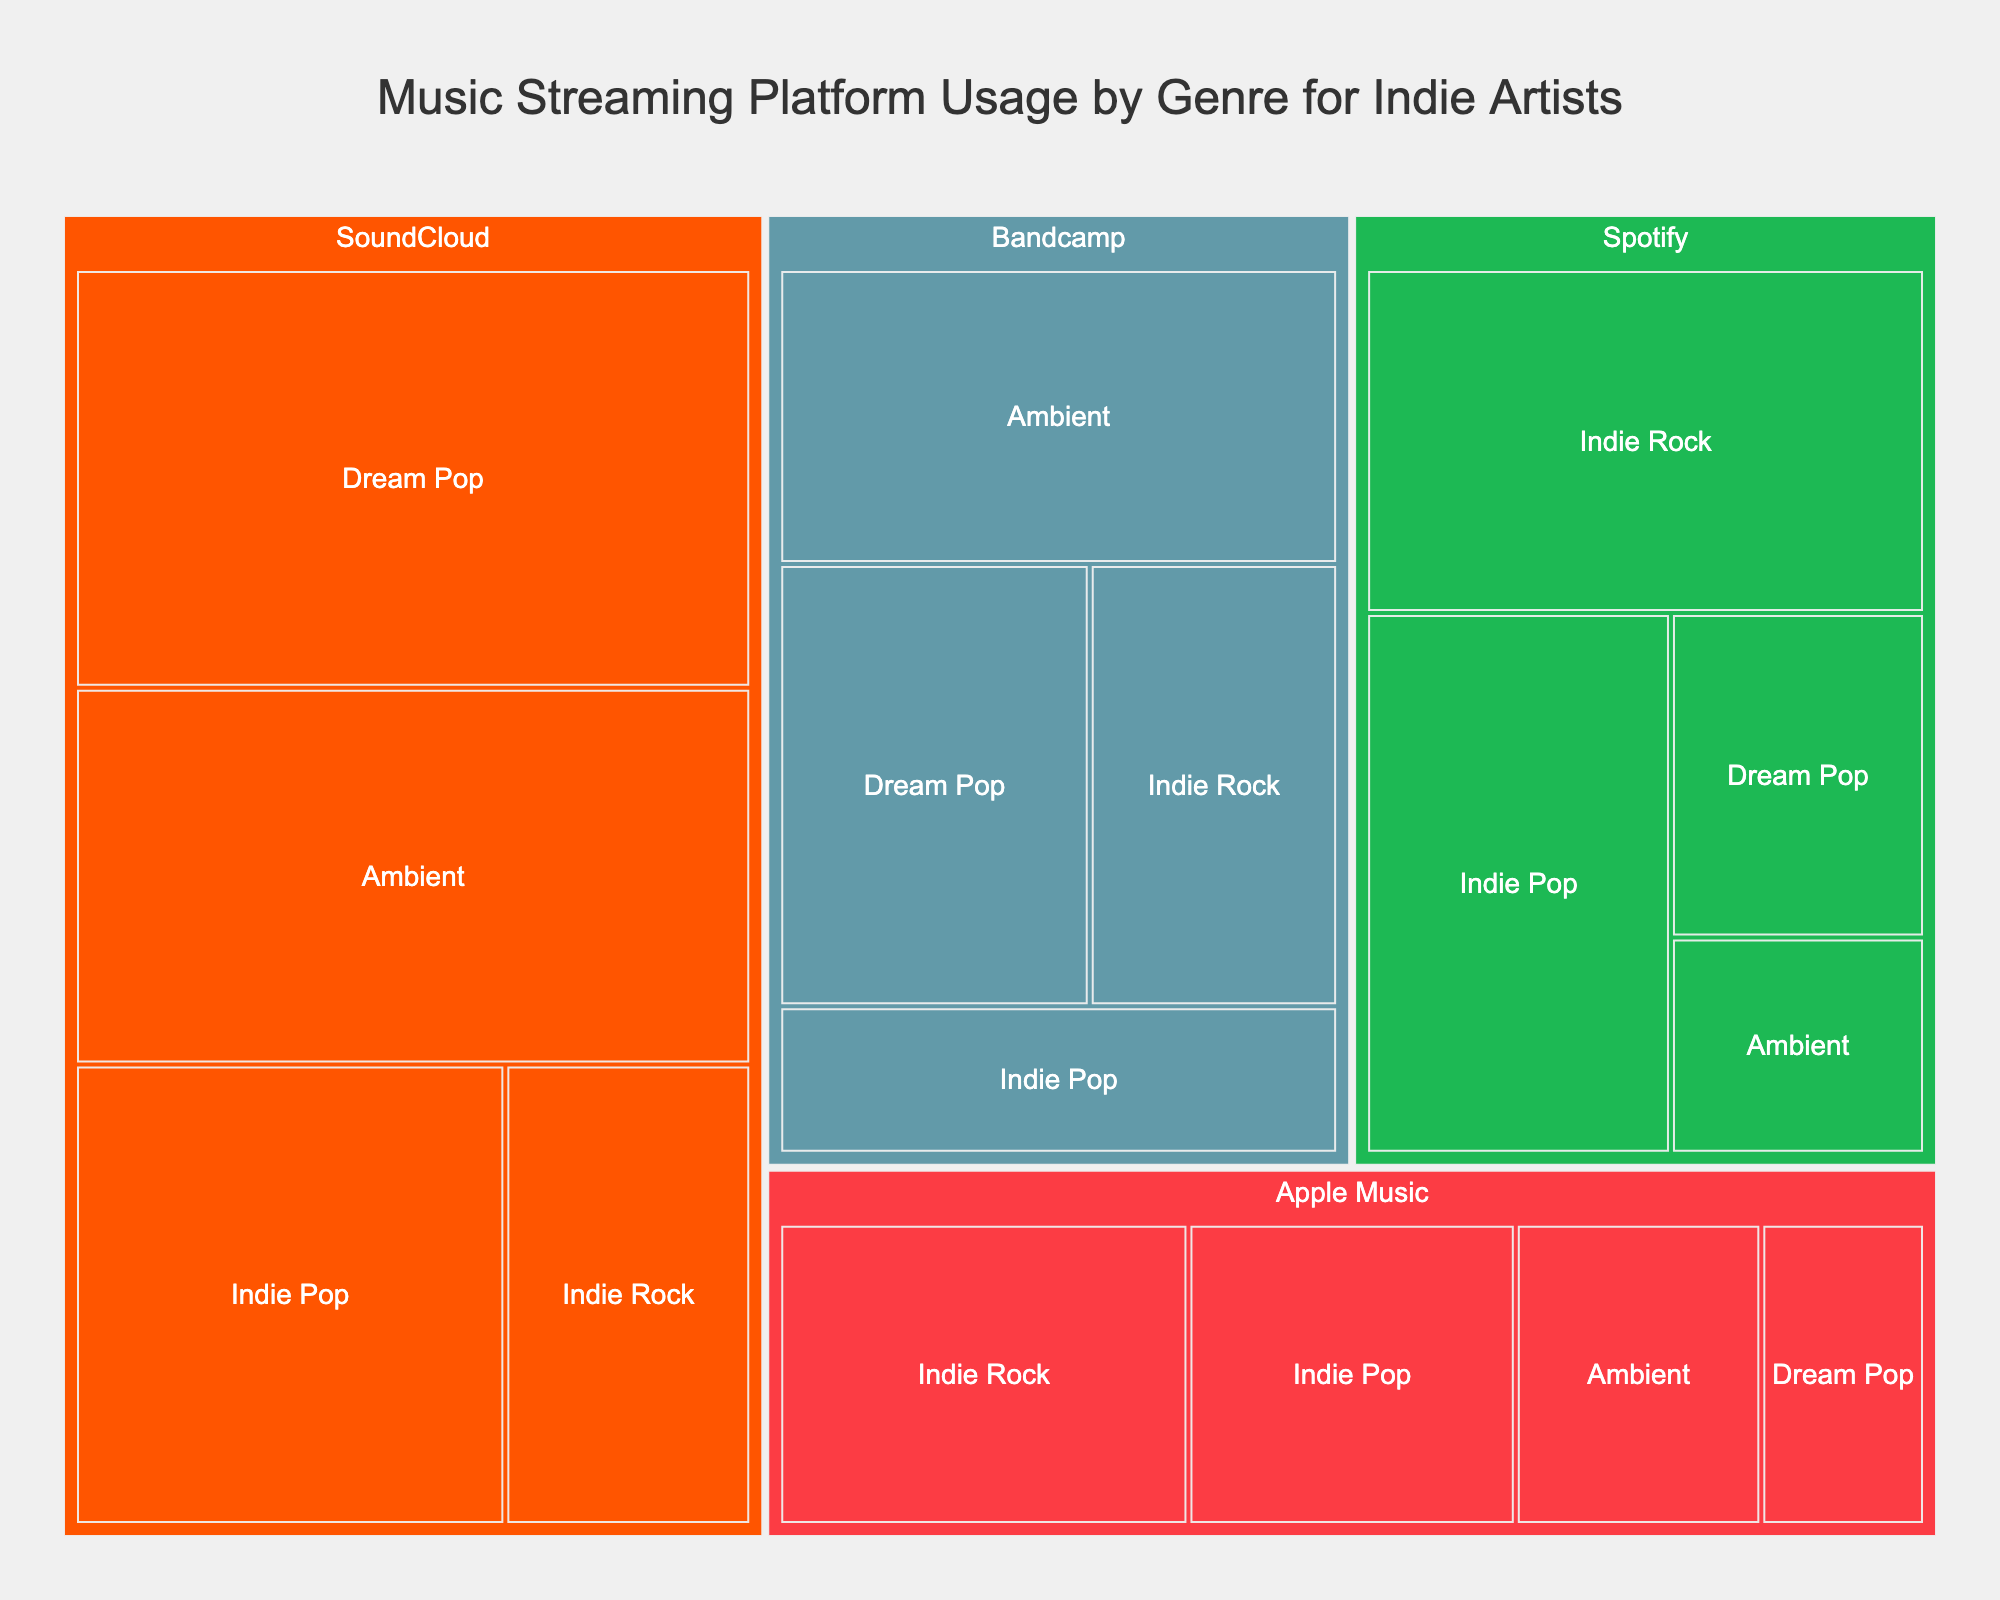what is the title of the Treemap? The title of the Treemap is displayed at the top center of the figure. It reads "Music Streaming Platform Usage by Genre for Indie Artists".
Answer: Music Streaming Platform Usage by Genre for Indie Artists What are the four platforms included in the Treemap? The Treemap visually represents four platforms, which can be identified by their distinct colors. They are: Spotify, Bandcamp, Apple Music, and SoundCloud.
Answer: Spotify, Bandcamp, Apple Music, SoundCloud How much percentage of Indie Pop streaming on Spotify? By locating the Spotify section in the Treemap and hovering over the Indie Pop block within it, the percentage displayed is 30%.
Answer: 30% Among Ambient genre, which platform has the highest usage percentage? To determine the platform with the highest usage for Ambient, examine the Ambient blocks within each platform section. The largest block with the highest value is in the SoundCloud section, representing 45%.
Answer: SoundCloud What is the combined percentage of Dream Pop on Bandcamp and Apple Music? For Dream Pop on Bandcamp, the percentage is 25%, and on Apple Music, it is 10%. Summing these two values gives: 25% + 10% = 35%.
Answer: 35% Which genre has the lowest streaming percentage on Apple Music? By examining the Apple Music section, the smallest block corresponds to Dream Pop, displaying a percentage of 10%.
Answer: Dream Pop How does the percentage of Indie Rock on Bandcamp compare to Indie Rock on SoundCloud? Identify the Indie Rock blocks within Bandcamp and SoundCloud sections. Bandcamp shows 20%, while SoundCloud shows 20%. Thus, their percentages are equal.
Answer: Equal What is the total percentage for Spotify across all genres? Sum the percentages for each genre within the Spotify section: Indie Rock (35%) + Indie Pop (30%) + Dream Pop (15%) + Ambient (10%) = 90%.
Answer: 90% Which platform and genre combination has the largest percentage? Examine the sizes of all blocks in the Treemap. The largest block is Dream Pop on SoundCloud, which shows the percentage as 50%.
Answer: SoundCloud, Dream Pop What is the average streaming percentage for Bandcamp across all genres? Sum the percentages for Bandcamp: Indie Rock (20%), Indie Pop (15%), Dream Pop (25%), Ambient (30%) and divide by 4. Calculation: (20% + 15% + 25% + 30%) / 4 = 22.5%.
Answer: 22.5% 